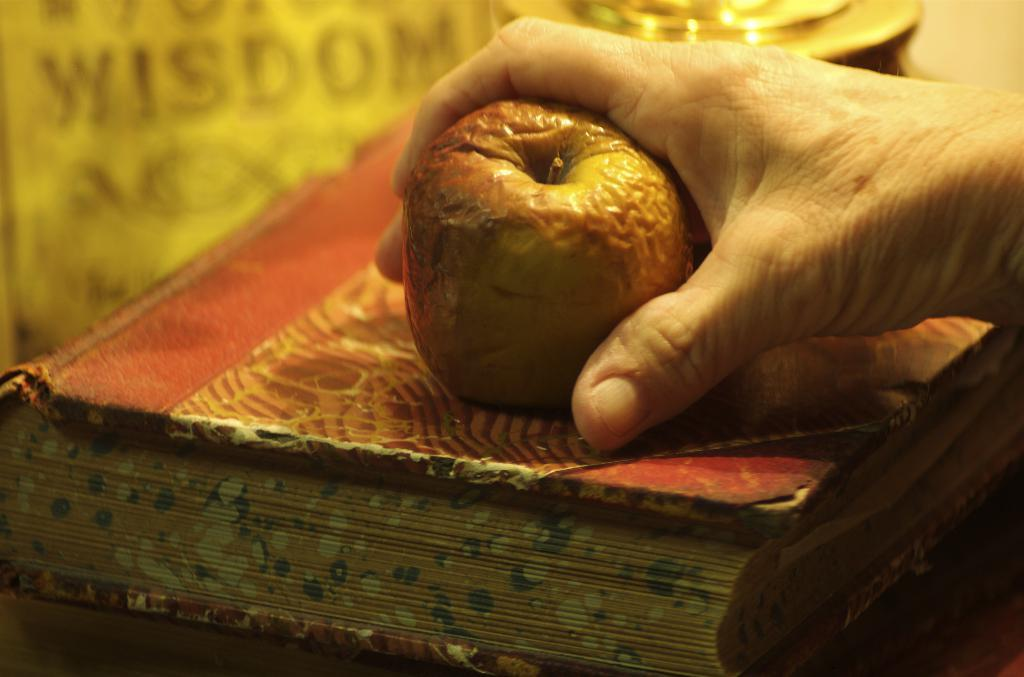What is the person holding in the image? The person is holding a fruit in the image. What is the fruit resting on? The fruit is on a book. What color is the background of the image? The background of the image is brown in color. How many pies are being served on the volleyball court in the image? There are no pies or volleyball courts present in the image. 